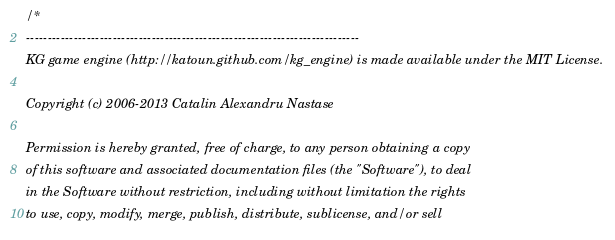Convert code to text. <code><loc_0><loc_0><loc_500><loc_500><_C++_>/*
-----------------------------------------------------------------------------
KG game engine (http://katoun.github.com/kg_engine) is made available under the MIT License.

Copyright (c) 2006-2013 Catalin Alexandru Nastase

Permission is hereby granted, free of charge, to any person obtaining a copy
of this software and associated documentation files (the "Software"), to deal
in the Software without restriction, including without limitation the rights
to use, copy, modify, merge, publish, distribute, sublicense, and/or sell</code> 